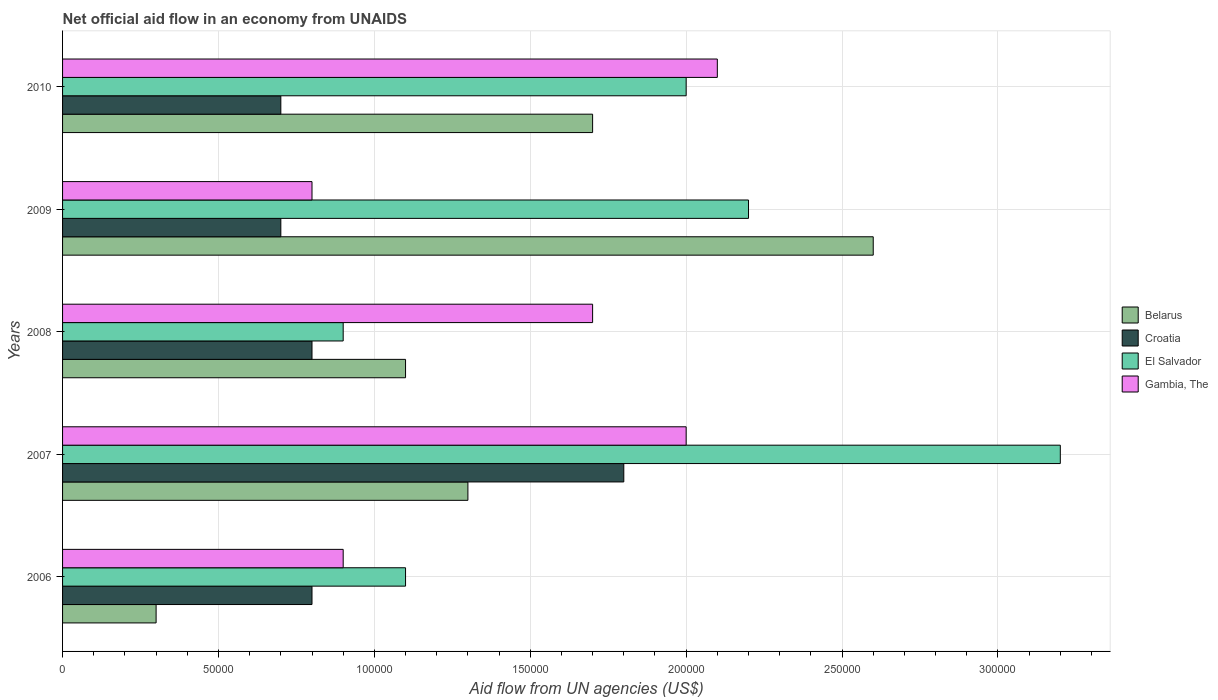How many different coloured bars are there?
Offer a terse response. 4. How many groups of bars are there?
Provide a succinct answer. 5. What is the label of the 1st group of bars from the top?
Your answer should be very brief. 2010. What is the net official aid flow in Croatia in 2006?
Ensure brevity in your answer.  8.00e+04. In which year was the net official aid flow in Gambia, The maximum?
Ensure brevity in your answer.  2010. What is the total net official aid flow in Gambia, The in the graph?
Make the answer very short. 7.50e+05. What is the difference between the net official aid flow in Belarus in 2007 and that in 2009?
Your answer should be very brief. -1.30e+05. What is the difference between the net official aid flow in Belarus in 2010 and the net official aid flow in El Salvador in 2007?
Your answer should be compact. -1.50e+05. What is the average net official aid flow in Croatia per year?
Ensure brevity in your answer.  9.60e+04. In how many years, is the net official aid flow in Croatia greater than 260000 US$?
Offer a terse response. 0. Is the net official aid flow in Gambia, The in 2008 less than that in 2010?
Ensure brevity in your answer.  Yes. In how many years, is the net official aid flow in Croatia greater than the average net official aid flow in Croatia taken over all years?
Offer a terse response. 1. Is the sum of the net official aid flow in Belarus in 2006 and 2008 greater than the maximum net official aid flow in El Salvador across all years?
Ensure brevity in your answer.  No. What does the 4th bar from the top in 2008 represents?
Your response must be concise. Belarus. What does the 1st bar from the bottom in 2009 represents?
Your answer should be compact. Belarus. Is it the case that in every year, the sum of the net official aid flow in Belarus and net official aid flow in El Salvador is greater than the net official aid flow in Croatia?
Ensure brevity in your answer.  Yes. Are all the bars in the graph horizontal?
Your response must be concise. Yes. How many years are there in the graph?
Your answer should be compact. 5. Does the graph contain any zero values?
Keep it short and to the point. No. Does the graph contain grids?
Offer a very short reply. Yes. Where does the legend appear in the graph?
Keep it short and to the point. Center right. How many legend labels are there?
Provide a short and direct response. 4. How are the legend labels stacked?
Your answer should be compact. Vertical. What is the title of the graph?
Offer a terse response. Net official aid flow in an economy from UNAIDS. What is the label or title of the X-axis?
Keep it short and to the point. Aid flow from UN agencies (US$). What is the label or title of the Y-axis?
Offer a terse response. Years. What is the Aid flow from UN agencies (US$) of Croatia in 2006?
Your answer should be very brief. 8.00e+04. What is the Aid flow from UN agencies (US$) of Croatia in 2007?
Offer a terse response. 1.80e+05. What is the Aid flow from UN agencies (US$) in Gambia, The in 2007?
Offer a very short reply. 2.00e+05. What is the Aid flow from UN agencies (US$) in El Salvador in 2008?
Keep it short and to the point. 9.00e+04. What is the Aid flow from UN agencies (US$) of Gambia, The in 2008?
Offer a terse response. 1.70e+05. What is the Aid flow from UN agencies (US$) of Belarus in 2009?
Make the answer very short. 2.60e+05. What is the Aid flow from UN agencies (US$) of Croatia in 2009?
Your response must be concise. 7.00e+04. What is the Aid flow from UN agencies (US$) in El Salvador in 2009?
Make the answer very short. 2.20e+05. What is the Aid flow from UN agencies (US$) in Gambia, The in 2009?
Provide a short and direct response. 8.00e+04. What is the Aid flow from UN agencies (US$) in Belarus in 2010?
Your answer should be compact. 1.70e+05. What is the Aid flow from UN agencies (US$) in Croatia in 2010?
Offer a terse response. 7.00e+04. What is the Aid flow from UN agencies (US$) of El Salvador in 2010?
Give a very brief answer. 2.00e+05. Across all years, what is the maximum Aid flow from UN agencies (US$) in Belarus?
Offer a very short reply. 2.60e+05. Across all years, what is the maximum Aid flow from UN agencies (US$) of Croatia?
Offer a very short reply. 1.80e+05. Across all years, what is the maximum Aid flow from UN agencies (US$) in El Salvador?
Provide a succinct answer. 3.20e+05. Across all years, what is the maximum Aid flow from UN agencies (US$) in Gambia, The?
Your answer should be very brief. 2.10e+05. Across all years, what is the minimum Aid flow from UN agencies (US$) of El Salvador?
Offer a terse response. 9.00e+04. What is the total Aid flow from UN agencies (US$) of El Salvador in the graph?
Make the answer very short. 9.40e+05. What is the total Aid flow from UN agencies (US$) of Gambia, The in the graph?
Offer a terse response. 7.50e+05. What is the difference between the Aid flow from UN agencies (US$) in Belarus in 2006 and that in 2007?
Make the answer very short. -1.00e+05. What is the difference between the Aid flow from UN agencies (US$) of Croatia in 2006 and that in 2008?
Your answer should be compact. 0. What is the difference between the Aid flow from UN agencies (US$) in El Salvador in 2006 and that in 2008?
Make the answer very short. 2.00e+04. What is the difference between the Aid flow from UN agencies (US$) in Gambia, The in 2006 and that in 2009?
Ensure brevity in your answer.  10000. What is the difference between the Aid flow from UN agencies (US$) in Belarus in 2006 and that in 2010?
Your answer should be compact. -1.40e+05. What is the difference between the Aid flow from UN agencies (US$) in Croatia in 2006 and that in 2010?
Keep it short and to the point. 10000. What is the difference between the Aid flow from UN agencies (US$) in El Salvador in 2006 and that in 2010?
Offer a very short reply. -9.00e+04. What is the difference between the Aid flow from UN agencies (US$) of Gambia, The in 2006 and that in 2010?
Make the answer very short. -1.20e+05. What is the difference between the Aid flow from UN agencies (US$) in Belarus in 2007 and that in 2008?
Your response must be concise. 2.00e+04. What is the difference between the Aid flow from UN agencies (US$) in Croatia in 2007 and that in 2008?
Your answer should be compact. 1.00e+05. What is the difference between the Aid flow from UN agencies (US$) of Croatia in 2007 and that in 2009?
Your response must be concise. 1.10e+05. What is the difference between the Aid flow from UN agencies (US$) of Belarus in 2007 and that in 2010?
Your response must be concise. -4.00e+04. What is the difference between the Aid flow from UN agencies (US$) of El Salvador in 2007 and that in 2010?
Give a very brief answer. 1.20e+05. What is the difference between the Aid flow from UN agencies (US$) of Belarus in 2008 and that in 2009?
Give a very brief answer. -1.50e+05. What is the difference between the Aid flow from UN agencies (US$) of Gambia, The in 2008 and that in 2009?
Make the answer very short. 9.00e+04. What is the difference between the Aid flow from UN agencies (US$) of El Salvador in 2008 and that in 2010?
Offer a very short reply. -1.10e+05. What is the difference between the Aid flow from UN agencies (US$) of Gambia, The in 2008 and that in 2010?
Offer a terse response. -4.00e+04. What is the difference between the Aid flow from UN agencies (US$) of Croatia in 2009 and that in 2010?
Your response must be concise. 0. What is the difference between the Aid flow from UN agencies (US$) of Belarus in 2006 and the Aid flow from UN agencies (US$) of Croatia in 2007?
Keep it short and to the point. -1.50e+05. What is the difference between the Aid flow from UN agencies (US$) of Belarus in 2006 and the Aid flow from UN agencies (US$) of El Salvador in 2007?
Your response must be concise. -2.90e+05. What is the difference between the Aid flow from UN agencies (US$) of Belarus in 2006 and the Aid flow from UN agencies (US$) of El Salvador in 2009?
Make the answer very short. -1.90e+05. What is the difference between the Aid flow from UN agencies (US$) in Croatia in 2006 and the Aid flow from UN agencies (US$) in El Salvador in 2009?
Give a very brief answer. -1.40e+05. What is the difference between the Aid flow from UN agencies (US$) of El Salvador in 2006 and the Aid flow from UN agencies (US$) of Gambia, The in 2009?
Provide a succinct answer. 3.00e+04. What is the difference between the Aid flow from UN agencies (US$) of Belarus in 2006 and the Aid flow from UN agencies (US$) of Croatia in 2010?
Ensure brevity in your answer.  -4.00e+04. What is the difference between the Aid flow from UN agencies (US$) of Belarus in 2006 and the Aid flow from UN agencies (US$) of El Salvador in 2010?
Offer a very short reply. -1.70e+05. What is the difference between the Aid flow from UN agencies (US$) of Belarus in 2006 and the Aid flow from UN agencies (US$) of Gambia, The in 2010?
Your answer should be very brief. -1.80e+05. What is the difference between the Aid flow from UN agencies (US$) of Belarus in 2007 and the Aid flow from UN agencies (US$) of El Salvador in 2008?
Make the answer very short. 4.00e+04. What is the difference between the Aid flow from UN agencies (US$) in Croatia in 2007 and the Aid flow from UN agencies (US$) in El Salvador in 2008?
Your answer should be very brief. 9.00e+04. What is the difference between the Aid flow from UN agencies (US$) of Croatia in 2007 and the Aid flow from UN agencies (US$) of Gambia, The in 2008?
Your answer should be compact. 10000. What is the difference between the Aid flow from UN agencies (US$) of Croatia in 2007 and the Aid flow from UN agencies (US$) of El Salvador in 2009?
Provide a short and direct response. -4.00e+04. What is the difference between the Aid flow from UN agencies (US$) of Croatia in 2007 and the Aid flow from UN agencies (US$) of Gambia, The in 2009?
Make the answer very short. 1.00e+05. What is the difference between the Aid flow from UN agencies (US$) of El Salvador in 2007 and the Aid flow from UN agencies (US$) of Gambia, The in 2009?
Make the answer very short. 2.40e+05. What is the difference between the Aid flow from UN agencies (US$) in Croatia in 2007 and the Aid flow from UN agencies (US$) in El Salvador in 2010?
Keep it short and to the point. -2.00e+04. What is the difference between the Aid flow from UN agencies (US$) in Croatia in 2007 and the Aid flow from UN agencies (US$) in Gambia, The in 2010?
Offer a terse response. -3.00e+04. What is the difference between the Aid flow from UN agencies (US$) in El Salvador in 2007 and the Aid flow from UN agencies (US$) in Gambia, The in 2010?
Offer a terse response. 1.10e+05. What is the difference between the Aid flow from UN agencies (US$) in Belarus in 2008 and the Aid flow from UN agencies (US$) in El Salvador in 2009?
Make the answer very short. -1.10e+05. What is the difference between the Aid flow from UN agencies (US$) of Belarus in 2008 and the Aid flow from UN agencies (US$) of Gambia, The in 2009?
Make the answer very short. 3.00e+04. What is the difference between the Aid flow from UN agencies (US$) in Croatia in 2008 and the Aid flow from UN agencies (US$) in El Salvador in 2009?
Your answer should be very brief. -1.40e+05. What is the difference between the Aid flow from UN agencies (US$) of Croatia in 2008 and the Aid flow from UN agencies (US$) of Gambia, The in 2009?
Provide a succinct answer. 0. What is the difference between the Aid flow from UN agencies (US$) of Belarus in 2008 and the Aid flow from UN agencies (US$) of Croatia in 2010?
Offer a terse response. 4.00e+04. What is the difference between the Aid flow from UN agencies (US$) in Belarus in 2008 and the Aid flow from UN agencies (US$) in El Salvador in 2010?
Ensure brevity in your answer.  -9.00e+04. What is the difference between the Aid flow from UN agencies (US$) of Croatia in 2008 and the Aid flow from UN agencies (US$) of El Salvador in 2010?
Give a very brief answer. -1.20e+05. What is the difference between the Aid flow from UN agencies (US$) in Croatia in 2008 and the Aid flow from UN agencies (US$) in Gambia, The in 2010?
Provide a succinct answer. -1.30e+05. What is the difference between the Aid flow from UN agencies (US$) in Belarus in 2009 and the Aid flow from UN agencies (US$) in Croatia in 2010?
Provide a succinct answer. 1.90e+05. What is the difference between the Aid flow from UN agencies (US$) in Belarus in 2009 and the Aid flow from UN agencies (US$) in El Salvador in 2010?
Offer a very short reply. 6.00e+04. What is the difference between the Aid flow from UN agencies (US$) in Belarus in 2009 and the Aid flow from UN agencies (US$) in Gambia, The in 2010?
Provide a succinct answer. 5.00e+04. What is the difference between the Aid flow from UN agencies (US$) of Croatia in 2009 and the Aid flow from UN agencies (US$) of El Salvador in 2010?
Your answer should be compact. -1.30e+05. What is the difference between the Aid flow from UN agencies (US$) of Croatia in 2009 and the Aid flow from UN agencies (US$) of Gambia, The in 2010?
Keep it short and to the point. -1.40e+05. What is the average Aid flow from UN agencies (US$) in Croatia per year?
Your answer should be very brief. 9.60e+04. What is the average Aid flow from UN agencies (US$) in El Salvador per year?
Provide a succinct answer. 1.88e+05. In the year 2006, what is the difference between the Aid flow from UN agencies (US$) in Belarus and Aid flow from UN agencies (US$) in Croatia?
Your response must be concise. -5.00e+04. In the year 2006, what is the difference between the Aid flow from UN agencies (US$) in Belarus and Aid flow from UN agencies (US$) in Gambia, The?
Your answer should be very brief. -6.00e+04. In the year 2006, what is the difference between the Aid flow from UN agencies (US$) of Croatia and Aid flow from UN agencies (US$) of Gambia, The?
Make the answer very short. -10000. In the year 2006, what is the difference between the Aid flow from UN agencies (US$) of El Salvador and Aid flow from UN agencies (US$) of Gambia, The?
Make the answer very short. 2.00e+04. In the year 2007, what is the difference between the Aid flow from UN agencies (US$) of Belarus and Aid flow from UN agencies (US$) of Croatia?
Your response must be concise. -5.00e+04. In the year 2007, what is the difference between the Aid flow from UN agencies (US$) in Belarus and Aid flow from UN agencies (US$) in El Salvador?
Your response must be concise. -1.90e+05. In the year 2007, what is the difference between the Aid flow from UN agencies (US$) of Croatia and Aid flow from UN agencies (US$) of El Salvador?
Provide a short and direct response. -1.40e+05. In the year 2007, what is the difference between the Aid flow from UN agencies (US$) of El Salvador and Aid flow from UN agencies (US$) of Gambia, The?
Provide a succinct answer. 1.20e+05. In the year 2008, what is the difference between the Aid flow from UN agencies (US$) in Belarus and Aid flow from UN agencies (US$) in El Salvador?
Provide a succinct answer. 2.00e+04. In the year 2008, what is the difference between the Aid flow from UN agencies (US$) of Croatia and Aid flow from UN agencies (US$) of Gambia, The?
Your answer should be compact. -9.00e+04. In the year 2009, what is the difference between the Aid flow from UN agencies (US$) of Belarus and Aid flow from UN agencies (US$) of Croatia?
Ensure brevity in your answer.  1.90e+05. In the year 2009, what is the difference between the Aid flow from UN agencies (US$) in Belarus and Aid flow from UN agencies (US$) in Gambia, The?
Make the answer very short. 1.80e+05. In the year 2010, what is the difference between the Aid flow from UN agencies (US$) in Belarus and Aid flow from UN agencies (US$) in Gambia, The?
Your response must be concise. -4.00e+04. In the year 2010, what is the difference between the Aid flow from UN agencies (US$) of Croatia and Aid flow from UN agencies (US$) of El Salvador?
Your response must be concise. -1.30e+05. What is the ratio of the Aid flow from UN agencies (US$) of Belarus in 2006 to that in 2007?
Keep it short and to the point. 0.23. What is the ratio of the Aid flow from UN agencies (US$) in Croatia in 2006 to that in 2007?
Your answer should be compact. 0.44. What is the ratio of the Aid flow from UN agencies (US$) in El Salvador in 2006 to that in 2007?
Your answer should be very brief. 0.34. What is the ratio of the Aid flow from UN agencies (US$) in Gambia, The in 2006 to that in 2007?
Give a very brief answer. 0.45. What is the ratio of the Aid flow from UN agencies (US$) of Belarus in 2006 to that in 2008?
Your response must be concise. 0.27. What is the ratio of the Aid flow from UN agencies (US$) in El Salvador in 2006 to that in 2008?
Offer a terse response. 1.22. What is the ratio of the Aid flow from UN agencies (US$) of Gambia, The in 2006 to that in 2008?
Give a very brief answer. 0.53. What is the ratio of the Aid flow from UN agencies (US$) in Belarus in 2006 to that in 2009?
Your answer should be compact. 0.12. What is the ratio of the Aid flow from UN agencies (US$) of Croatia in 2006 to that in 2009?
Make the answer very short. 1.14. What is the ratio of the Aid flow from UN agencies (US$) of Gambia, The in 2006 to that in 2009?
Give a very brief answer. 1.12. What is the ratio of the Aid flow from UN agencies (US$) of Belarus in 2006 to that in 2010?
Offer a very short reply. 0.18. What is the ratio of the Aid flow from UN agencies (US$) in Croatia in 2006 to that in 2010?
Ensure brevity in your answer.  1.14. What is the ratio of the Aid flow from UN agencies (US$) in El Salvador in 2006 to that in 2010?
Offer a terse response. 0.55. What is the ratio of the Aid flow from UN agencies (US$) in Gambia, The in 2006 to that in 2010?
Offer a very short reply. 0.43. What is the ratio of the Aid flow from UN agencies (US$) of Belarus in 2007 to that in 2008?
Offer a very short reply. 1.18. What is the ratio of the Aid flow from UN agencies (US$) in Croatia in 2007 to that in 2008?
Your response must be concise. 2.25. What is the ratio of the Aid flow from UN agencies (US$) of El Salvador in 2007 to that in 2008?
Provide a succinct answer. 3.56. What is the ratio of the Aid flow from UN agencies (US$) of Gambia, The in 2007 to that in 2008?
Provide a short and direct response. 1.18. What is the ratio of the Aid flow from UN agencies (US$) in Croatia in 2007 to that in 2009?
Give a very brief answer. 2.57. What is the ratio of the Aid flow from UN agencies (US$) in El Salvador in 2007 to that in 2009?
Offer a very short reply. 1.45. What is the ratio of the Aid flow from UN agencies (US$) in Belarus in 2007 to that in 2010?
Provide a short and direct response. 0.76. What is the ratio of the Aid flow from UN agencies (US$) of Croatia in 2007 to that in 2010?
Your response must be concise. 2.57. What is the ratio of the Aid flow from UN agencies (US$) of Belarus in 2008 to that in 2009?
Ensure brevity in your answer.  0.42. What is the ratio of the Aid flow from UN agencies (US$) of El Salvador in 2008 to that in 2009?
Provide a short and direct response. 0.41. What is the ratio of the Aid flow from UN agencies (US$) in Gambia, The in 2008 to that in 2009?
Your response must be concise. 2.12. What is the ratio of the Aid flow from UN agencies (US$) of Belarus in 2008 to that in 2010?
Provide a short and direct response. 0.65. What is the ratio of the Aid flow from UN agencies (US$) of El Salvador in 2008 to that in 2010?
Your answer should be very brief. 0.45. What is the ratio of the Aid flow from UN agencies (US$) in Gambia, The in 2008 to that in 2010?
Offer a terse response. 0.81. What is the ratio of the Aid flow from UN agencies (US$) of Belarus in 2009 to that in 2010?
Keep it short and to the point. 1.53. What is the ratio of the Aid flow from UN agencies (US$) in El Salvador in 2009 to that in 2010?
Your response must be concise. 1.1. What is the ratio of the Aid flow from UN agencies (US$) in Gambia, The in 2009 to that in 2010?
Offer a very short reply. 0.38. What is the difference between the highest and the second highest Aid flow from UN agencies (US$) of El Salvador?
Your answer should be very brief. 1.00e+05. What is the difference between the highest and the lowest Aid flow from UN agencies (US$) of El Salvador?
Make the answer very short. 2.30e+05. 